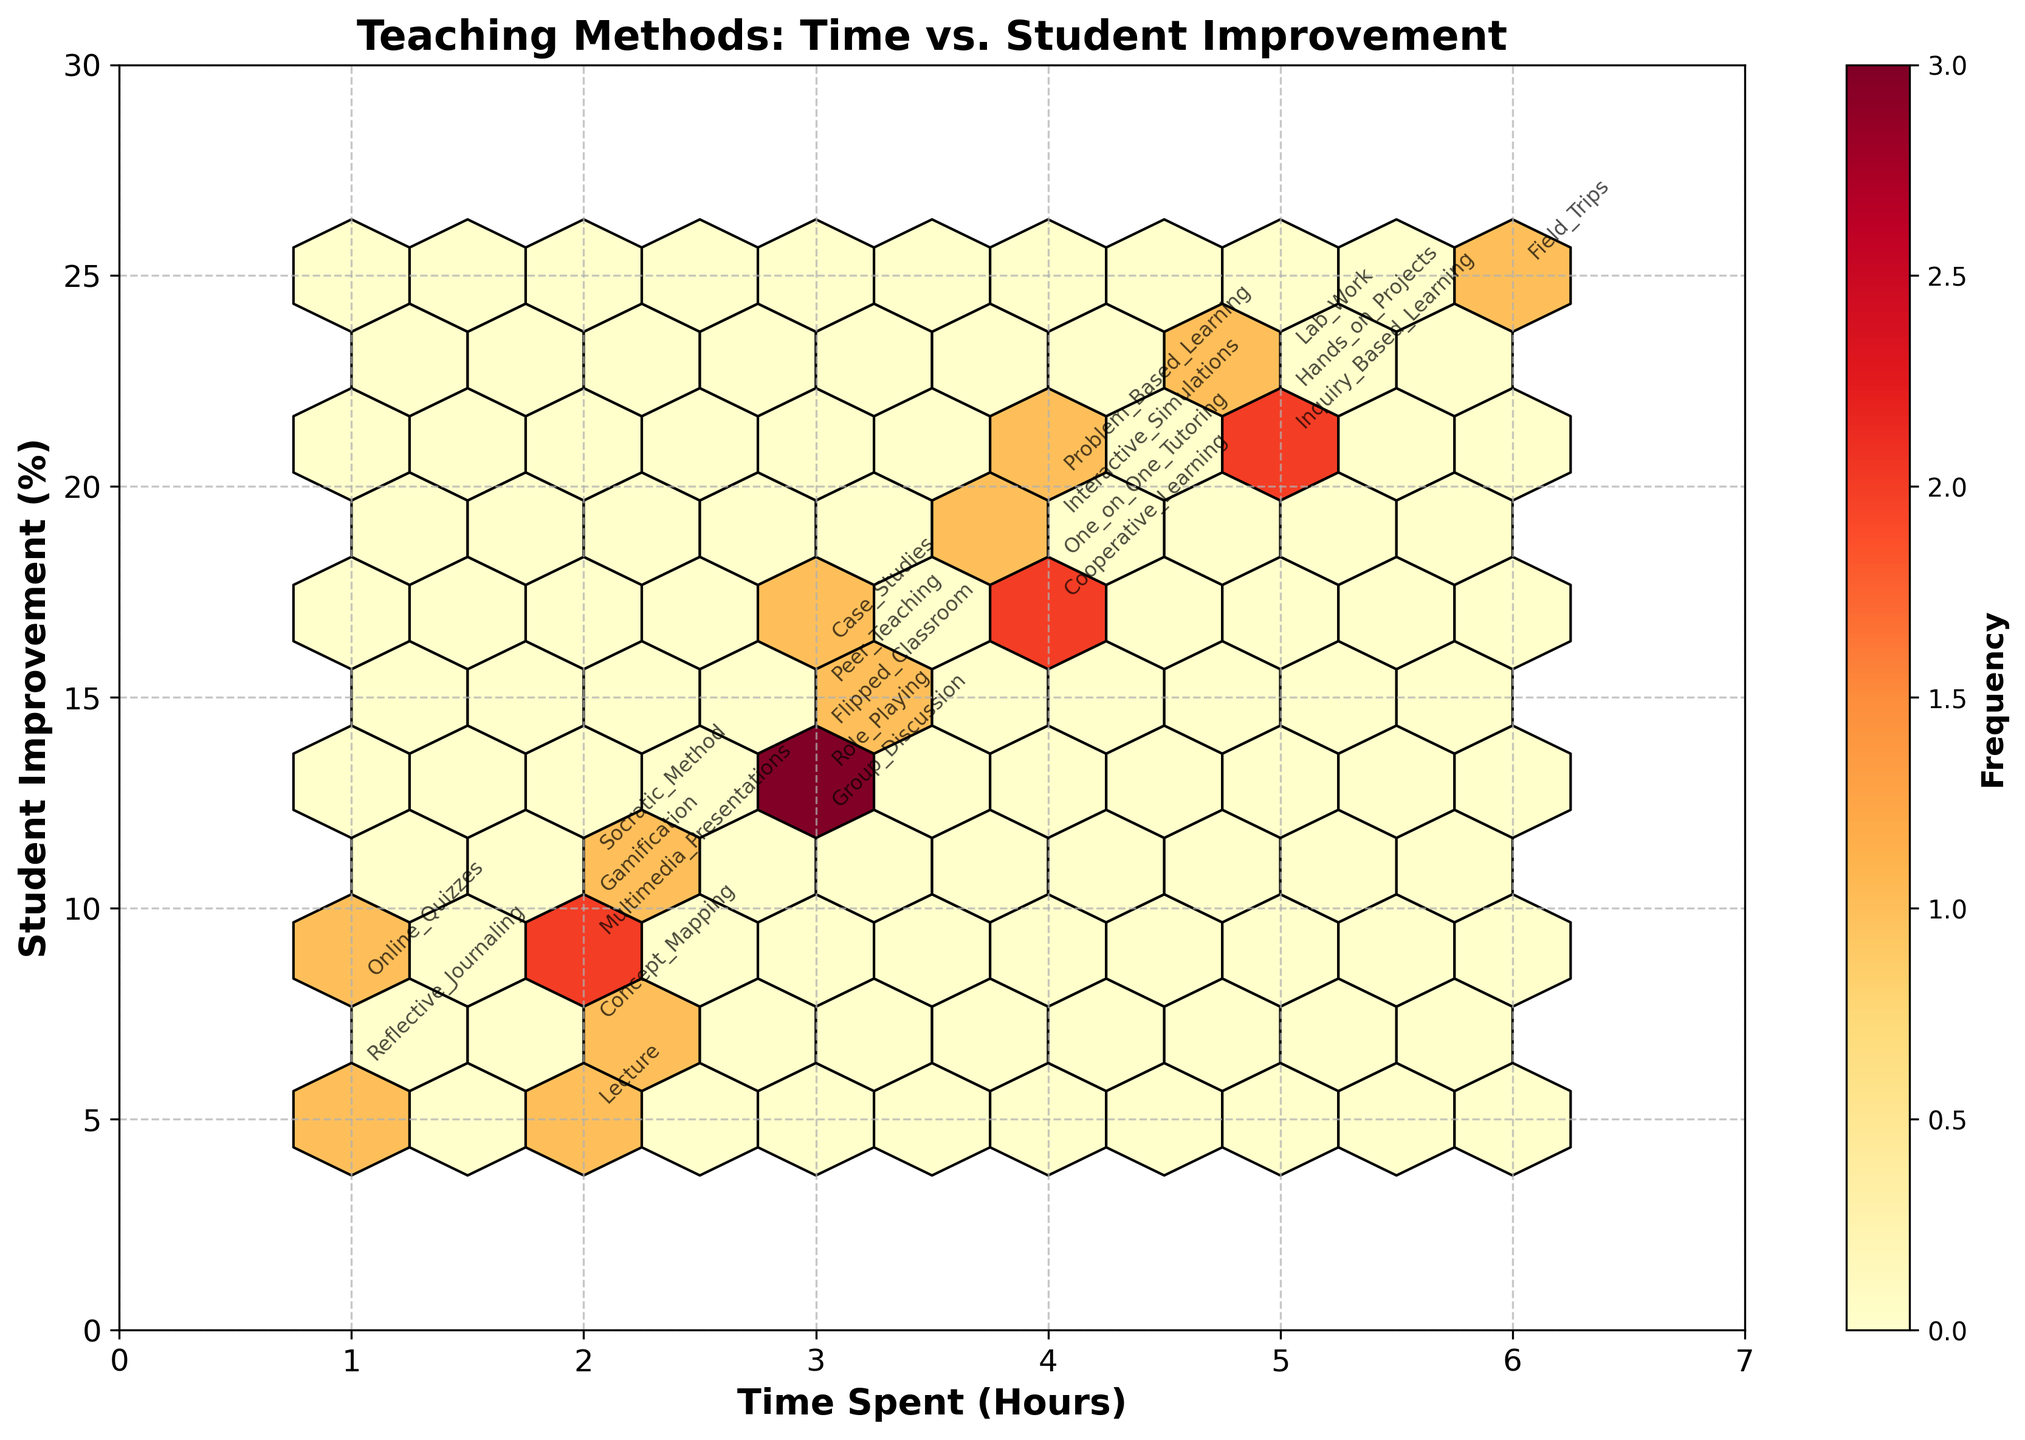What's the title of the figure? The title of the figure is usually displayed at the top. By looking at the top section of the figure, you can identify it.
Answer: Teaching Methods: Time vs. Student Improvement What does the x-axis represent? The label on the x-axis indicates what it represents. By reading this label, you can determine its meaning.
Answer: Time Spent (Hours) What color scale is used in the hexbin plot? The color scale is shown in the legend or colorbar on the side of the plot. By observing the shades, it can be identified.
Answer: YlOrRd (Yellow-Orange-Red) How many data points are located in the grid where Time Spent (Hours) is 3 and Student Improvement (%) is 14? By checking the specific hexbin cell corresponding to Time Spent = 3 and Student Improvement Rate = 14, you can count the points.
Answer: It represents one teaching method: Flipped Classroom Which teaching method results in the highest student improvement? Look at the y-axis to identify which hexbin contains the highest value, and refer to the annotations to find the corresponding teaching method.
Answer: Field Trips How many methods have a time spent of 4 hours? By counting the hexbin cells or points where the x-value is 4, you can determine the number of methods.
Answer: 4 Which teaching methods fall into the range of a time spent of 2 hours? Locate the hexbin cells where the x-axis shows 2 hours and read the annotated method names.
Answer: Lecture, Gamification, Socratic Method, Multimedia Presentations, Concept Mapping What is the difference in student improvement between Hands-on Projects and Reflective Journaling? Find the y-values (Student Improvement %) for these methods and subtract the value of Reflective Journaling from Hands-on Projects. Hands-on Projects have 22%, and Reflective Journaling has 6%. So, 22 - 6 = 16.
Answer: 16 Which teaching method has the least time spent but greater than 10% student improvement? Identify the method with the smallest x-value (time spent) and a y-value (improvement rate) greater than 10%. It is Socratic Method with a time spent of 2 hours and an improvement rate of 11%.
Answer: Socratic Method What is the average student improvement for methods with a time spent of 3 hours? Identify the methods with 3 hours time spent, sum their student improvement rates, and divide by the number of methods. Group Discussion (12), Peer Teaching (15), Flipped Classroom (14), Case Studies (16), Role Playing (13). So, (12+15+14+16+13)/5 = 70/5 = 14.
Answer: 14 